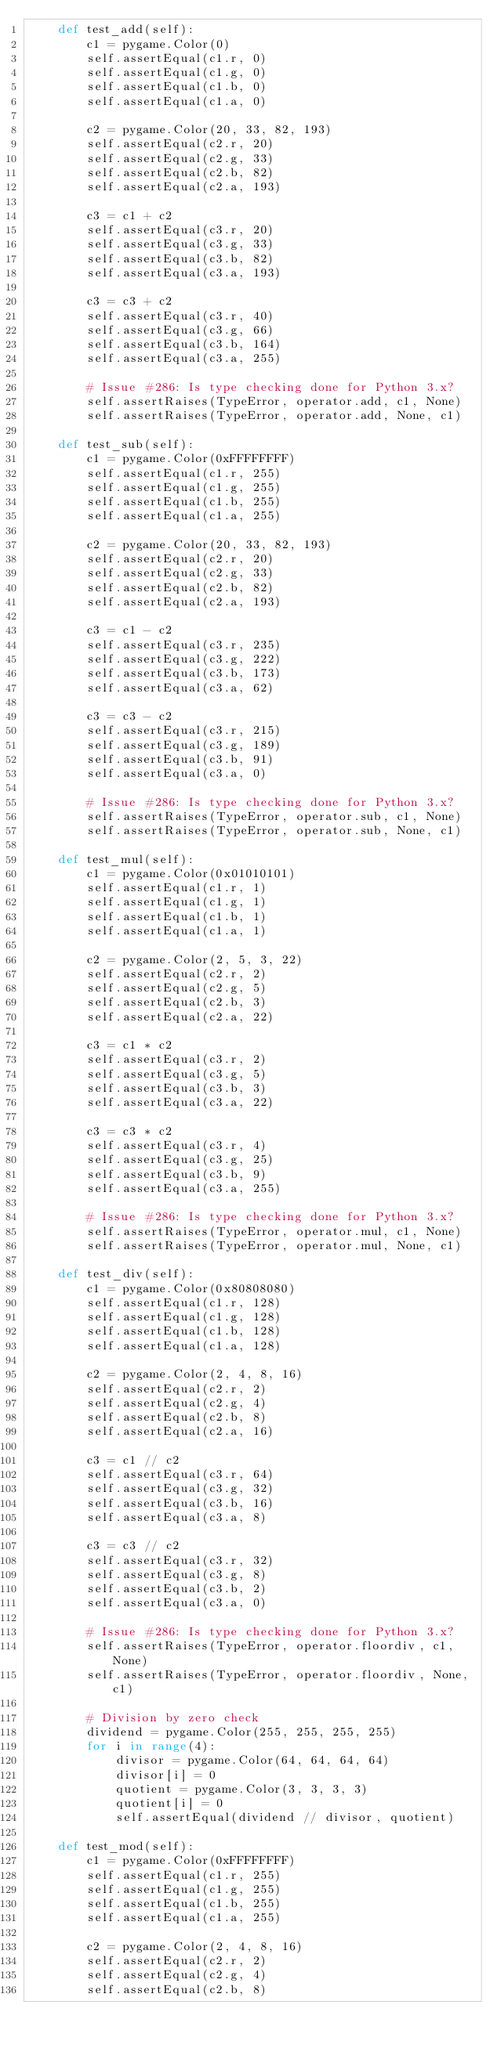<code> <loc_0><loc_0><loc_500><loc_500><_Python_>    def test_add(self):
        c1 = pygame.Color(0)
        self.assertEqual(c1.r, 0)
        self.assertEqual(c1.g, 0)
        self.assertEqual(c1.b, 0)
        self.assertEqual(c1.a, 0)

        c2 = pygame.Color(20, 33, 82, 193)
        self.assertEqual(c2.r, 20)
        self.assertEqual(c2.g, 33)
        self.assertEqual(c2.b, 82)
        self.assertEqual(c2.a, 193)

        c3 = c1 + c2
        self.assertEqual(c3.r, 20)
        self.assertEqual(c3.g, 33)
        self.assertEqual(c3.b, 82)
        self.assertEqual(c3.a, 193)

        c3 = c3 + c2
        self.assertEqual(c3.r, 40)
        self.assertEqual(c3.g, 66)
        self.assertEqual(c3.b, 164)
        self.assertEqual(c3.a, 255)

        # Issue #286: Is type checking done for Python 3.x?
        self.assertRaises(TypeError, operator.add, c1, None)
        self.assertRaises(TypeError, operator.add, None, c1)

    def test_sub(self):
        c1 = pygame.Color(0xFFFFFFFF)
        self.assertEqual(c1.r, 255)
        self.assertEqual(c1.g, 255)
        self.assertEqual(c1.b, 255)
        self.assertEqual(c1.a, 255)

        c2 = pygame.Color(20, 33, 82, 193)
        self.assertEqual(c2.r, 20)
        self.assertEqual(c2.g, 33)
        self.assertEqual(c2.b, 82)
        self.assertEqual(c2.a, 193)

        c3 = c1 - c2
        self.assertEqual(c3.r, 235)
        self.assertEqual(c3.g, 222)
        self.assertEqual(c3.b, 173)
        self.assertEqual(c3.a, 62)

        c3 = c3 - c2
        self.assertEqual(c3.r, 215)
        self.assertEqual(c3.g, 189)
        self.assertEqual(c3.b, 91)
        self.assertEqual(c3.a, 0)

        # Issue #286: Is type checking done for Python 3.x?
        self.assertRaises(TypeError, operator.sub, c1, None)
        self.assertRaises(TypeError, operator.sub, None, c1)

    def test_mul(self):
        c1 = pygame.Color(0x01010101)
        self.assertEqual(c1.r, 1)
        self.assertEqual(c1.g, 1)
        self.assertEqual(c1.b, 1)
        self.assertEqual(c1.a, 1)

        c2 = pygame.Color(2, 5, 3, 22)
        self.assertEqual(c2.r, 2)
        self.assertEqual(c2.g, 5)
        self.assertEqual(c2.b, 3)
        self.assertEqual(c2.a, 22)

        c3 = c1 * c2
        self.assertEqual(c3.r, 2)
        self.assertEqual(c3.g, 5)
        self.assertEqual(c3.b, 3)
        self.assertEqual(c3.a, 22)

        c3 = c3 * c2
        self.assertEqual(c3.r, 4)
        self.assertEqual(c3.g, 25)
        self.assertEqual(c3.b, 9)
        self.assertEqual(c3.a, 255)

        # Issue #286: Is type checking done for Python 3.x?
        self.assertRaises(TypeError, operator.mul, c1, None)
        self.assertRaises(TypeError, operator.mul, None, c1)

    def test_div(self):
        c1 = pygame.Color(0x80808080)
        self.assertEqual(c1.r, 128)
        self.assertEqual(c1.g, 128)
        self.assertEqual(c1.b, 128)
        self.assertEqual(c1.a, 128)

        c2 = pygame.Color(2, 4, 8, 16)
        self.assertEqual(c2.r, 2)
        self.assertEqual(c2.g, 4)
        self.assertEqual(c2.b, 8)
        self.assertEqual(c2.a, 16)

        c3 = c1 // c2
        self.assertEqual(c3.r, 64)
        self.assertEqual(c3.g, 32)
        self.assertEqual(c3.b, 16)
        self.assertEqual(c3.a, 8)

        c3 = c3 // c2
        self.assertEqual(c3.r, 32)
        self.assertEqual(c3.g, 8)
        self.assertEqual(c3.b, 2)
        self.assertEqual(c3.a, 0)

        # Issue #286: Is type checking done for Python 3.x?
        self.assertRaises(TypeError, operator.floordiv, c1, None)
        self.assertRaises(TypeError, operator.floordiv, None, c1)

        # Division by zero check
        dividend = pygame.Color(255, 255, 255, 255)
        for i in range(4):
            divisor = pygame.Color(64, 64, 64, 64)
            divisor[i] = 0
            quotient = pygame.Color(3, 3, 3, 3)
            quotient[i] = 0
            self.assertEqual(dividend // divisor, quotient)

    def test_mod(self):
        c1 = pygame.Color(0xFFFFFFFF)
        self.assertEqual(c1.r, 255)
        self.assertEqual(c1.g, 255)
        self.assertEqual(c1.b, 255)
        self.assertEqual(c1.a, 255)

        c2 = pygame.Color(2, 4, 8, 16)
        self.assertEqual(c2.r, 2)
        self.assertEqual(c2.g, 4)
        self.assertEqual(c2.b, 8)</code> 